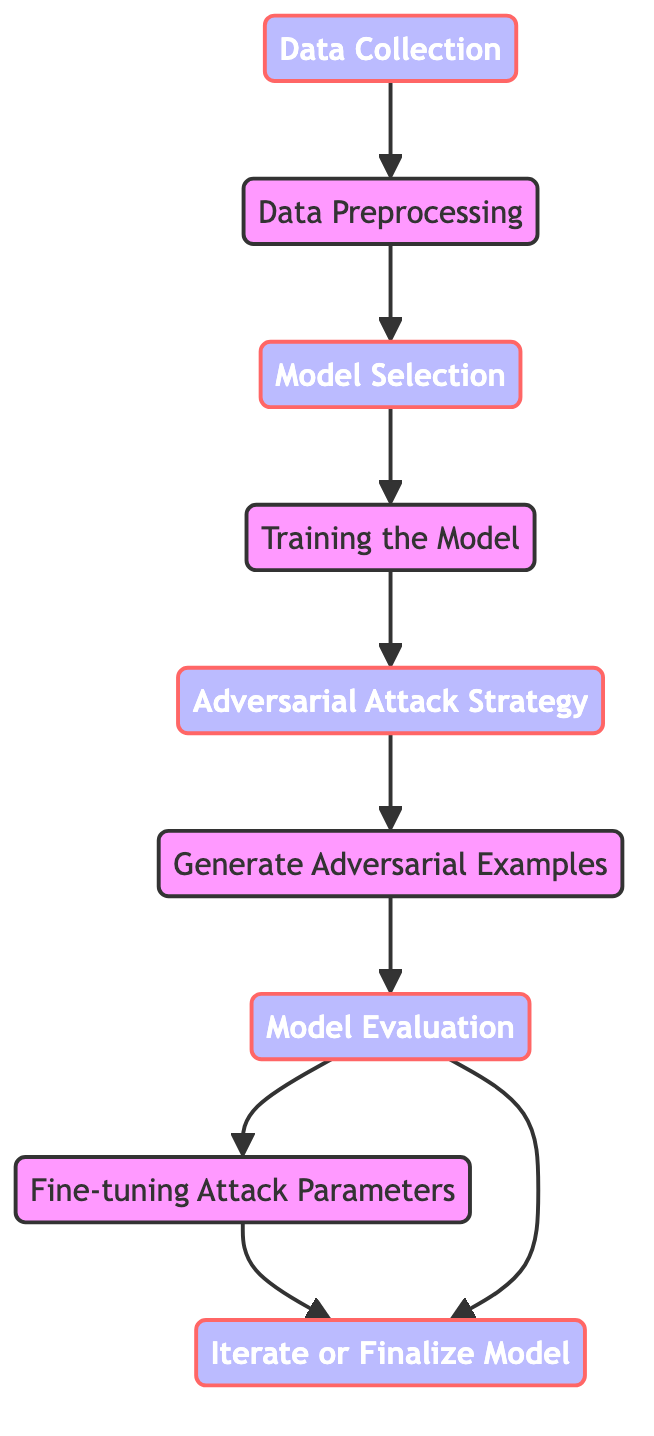What's the starting point of the workflow? The workflow begins at the "Data Collection" node, which is the first node in the directed graph, indicating that this is the initial step.
Answer: Data Collection How many nodes are in the diagram? Counting all distinct labeled nodes in the directed graph, we find that there are nine nodes in total.
Answer: 9 What is the last step in the workflow? The final output of the workflow is at the "Iterate or Finalize Model" node, which is the last node reachable from others.
Answer: Iterate or Finalize Model Which two nodes are connected directly by an edge after "Model Evaluation"? "Model Evaluation" connects directly to "Fine-tuning Attack Parameters" and also directly to "Iterate or Finalize Model", showing two possible paths from this step.
Answer: Fine-tuning Attack Parameters, Iterate or Finalize Model What is the relationship between "Adversarial Attack Strategy" and "Generate Adversarial Examples"? There is a directed edge leading from "Adversarial Attack Strategy" to "Generate Adversarial Examples", indicating that the former is a prerequisite for the latter in the workflow.
Answer: Adversarial Attack Strategy → Generate Adversarial Examples How many edges are coming out of "Model Evaluation"? The "Model Evaluation" node has two outgoing edges: one to "Fine-tuning Attack Parameters" and another to "Iterate or Finalize Model".
Answer: 2 What is the node that directly follows "Training the Model"? The node that comes directly after "Training the Model" in the flow is "Adversarial Attack Strategy", showing a sequential action in the workflow.
Answer: Adversarial Attack Strategy Which step follows "Generate Adversarial Examples"? The next step after "Generate Adversarial Examples" is "Model Evaluation", indicating this is where the generated examples are assessed.
Answer: Model Evaluation What is the primary purpose of the "Fine-tuning Attack Parameters" node in the workflow? The "Fine-tuning Attack Parameters" node is dedicated to refining the parameters used in previous steps to enhance the quality of the adversarial attacks.
Answer: Refine attack parameters 